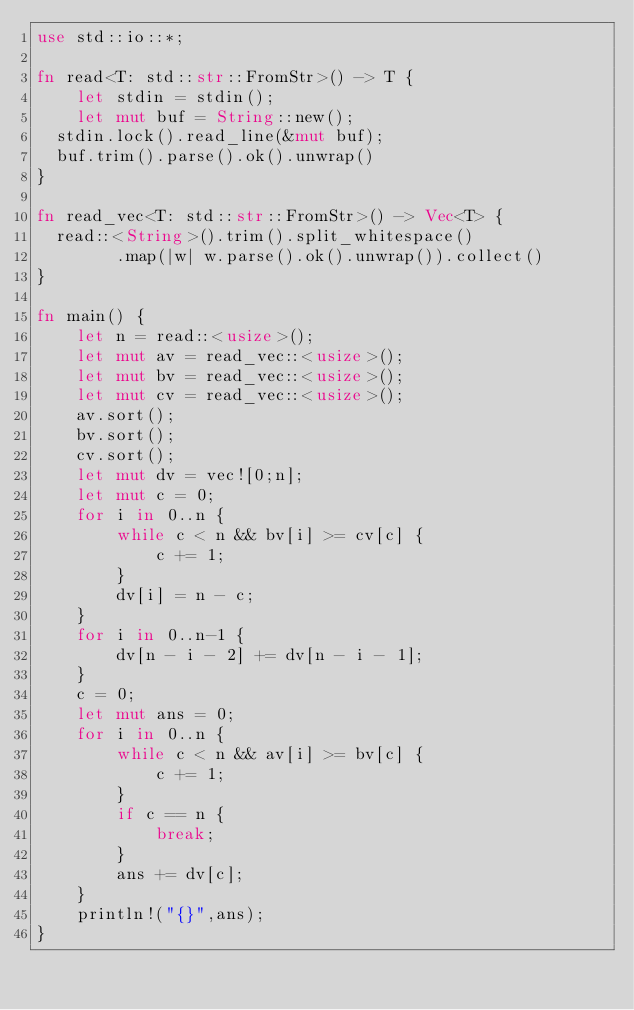Convert code to text. <code><loc_0><loc_0><loc_500><loc_500><_Rust_>use std::io::*;

fn read<T: std::str::FromStr>() -> T {
    let stdin = stdin();
    let mut buf = String::new();
	stdin.lock().read_line(&mut buf);
	buf.trim().parse().ok().unwrap()
}

fn read_vec<T: std::str::FromStr>() -> Vec<T> {
	read::<String>().trim().split_whitespace()
        .map(|w| w.parse().ok().unwrap()).collect()
}

fn main() {
    let n = read::<usize>();
    let mut av = read_vec::<usize>();
    let mut bv = read_vec::<usize>();
    let mut cv = read_vec::<usize>();
    av.sort();
    bv.sort();
    cv.sort();
    let mut dv = vec![0;n];
    let mut c = 0;
    for i in 0..n {
        while c < n && bv[i] >= cv[c] {
            c += 1;
        }
        dv[i] = n - c;
    }
    for i in 0..n-1 {
        dv[n - i - 2] += dv[n - i - 1];
    }
    c = 0;
    let mut ans = 0;
    for i in 0..n {
        while c < n && av[i] >= bv[c] {
            c += 1;
        }
        if c == n {
            break;
        }
        ans += dv[c];
    }
    println!("{}",ans);
}
</code> 